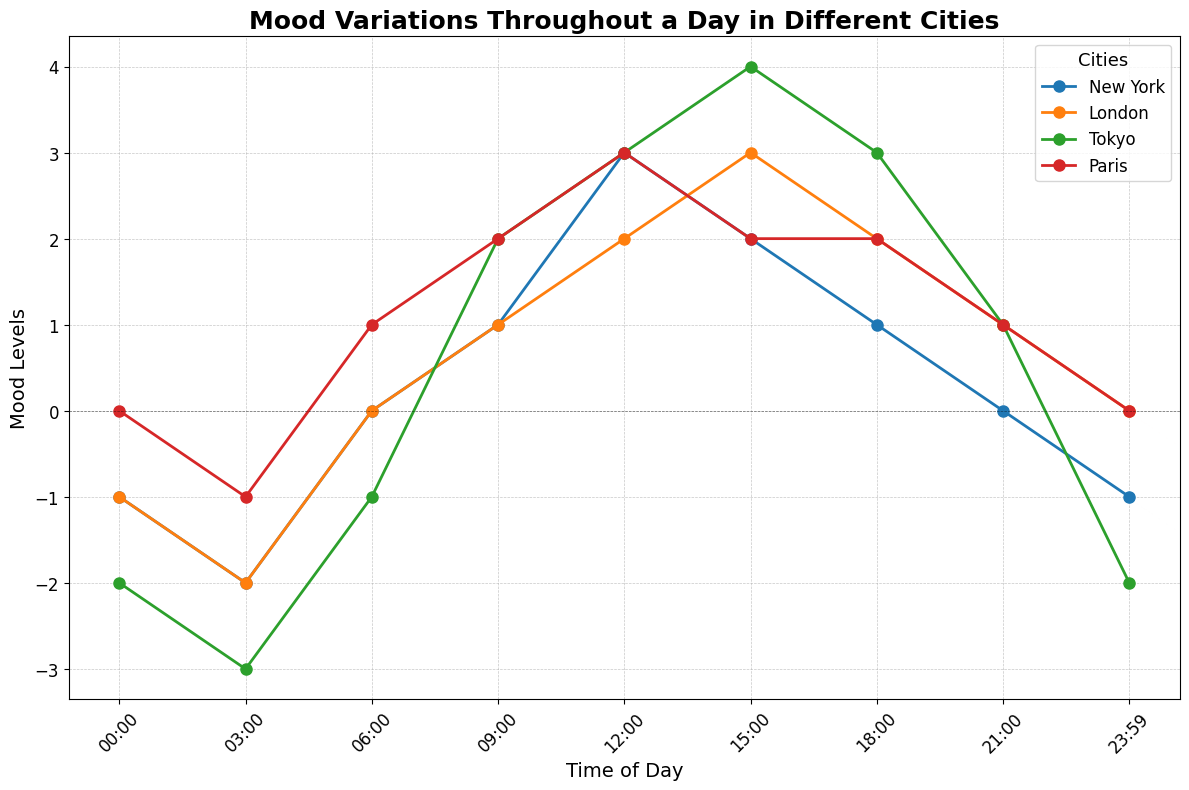What's the highest mood level observed in all cities throughout the day? The highest mood level occurs when the line reaches its peak on the y-axis. Tokyo shows the highest mood level of 4 at 15:00.
Answer: 4 Which city starts the day with the lowest mood level at 00:00? At 00:00, compare the mood levels of all cities. Tokyo has the lowest mood level, which is -2.
Answer: Tokyo How does the mood in New York compare to London at 15:00? Both New York and London have mood levels at 15:00. New York has a mood level of 2, while London has a mood level of 3.
Answer: London's mood is higher Is there any city where the mood level does not drop below zero throughout the day? By tracing each city's mood level line, Paris is the only city whose mood level stays above or equal to zero throughout the day.
Answer: Paris What's the average mood level of Tokyo at 06:00 and 09:00? At 06:00, Tokyo's mood level is -1. At 09:00, it is 2. The average is calculated as (-1 + 2) / 2 = 0.5.
Answer: 0.5 Which city experiences the largest drop in mood level between two time points? Identify the largest drop by comparing the changes between time points for all cities. Tokyo drops from 1 to -2 between 21:00 and 23:59, a drop of 3.
Answer: Tokyo What is the difference in mood levels between New York and Paris at 09:00? At 09:00, New York's mood level is 1, and Paris's mood level is 2. The difference is 2 - 1 = 1.
Answer: 1 During which time period does London show the highest increase in mood level? Track the time periods in which London's mood level increases the most. The highest increase is from 3:00 (-2) to 6:00 (0), which is an increase of 2 levels.
Answer: 03:00 - 06:00 For New York, what's the sum of mood levels at 03:00, 12:00, and 21:00? New York's mood levels at the specified times are: 03:00 (-2), 12:00 (3), and 21:00 (0). The sum is -2 + 3 + 0 = 1.
Answer: 1 What’s the mood level difference between the highest and lowest points in Tokyo? The highest mood level in Tokyo is 4 at 15:00, and the lowest is -3 at 03:00. The difference is 4 - (-3) = 7.
Answer: 7 